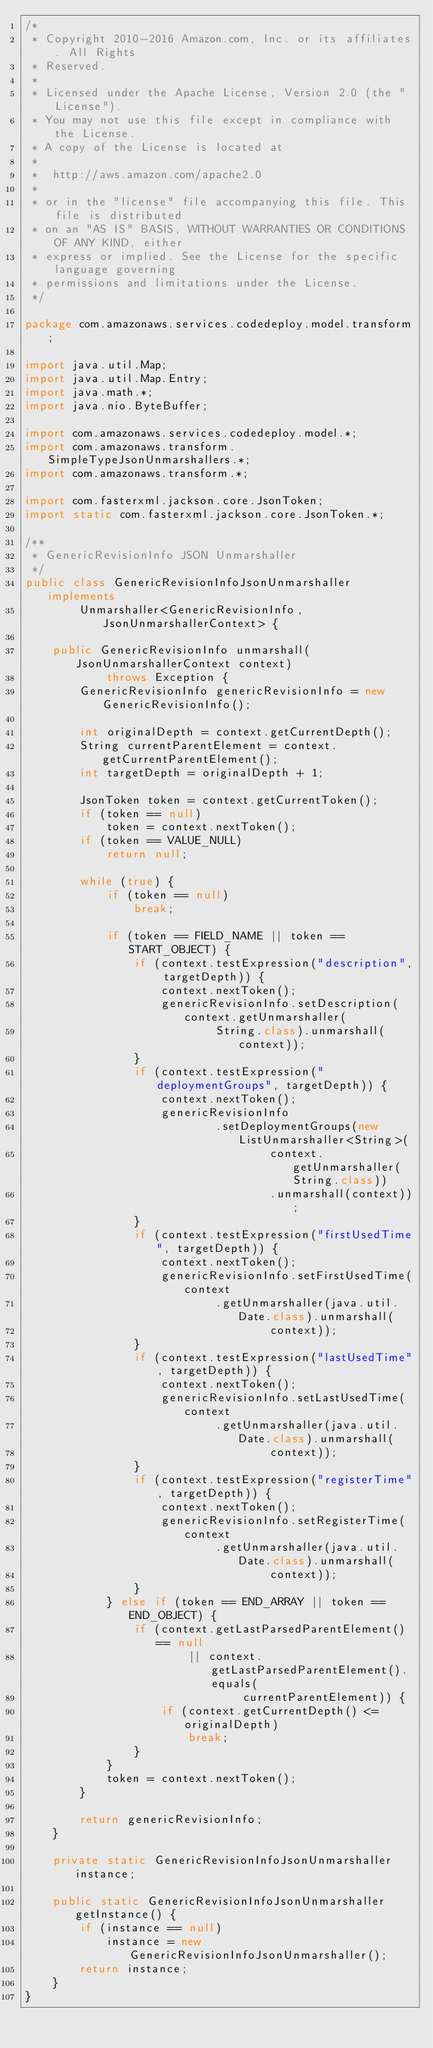Convert code to text. <code><loc_0><loc_0><loc_500><loc_500><_Java_>/*
 * Copyright 2010-2016 Amazon.com, Inc. or its affiliates. All Rights
 * Reserved.
 *
 * Licensed under the Apache License, Version 2.0 (the "License").
 * You may not use this file except in compliance with the License.
 * A copy of the License is located at
 *
 *  http://aws.amazon.com/apache2.0
 *
 * or in the "license" file accompanying this file. This file is distributed
 * on an "AS IS" BASIS, WITHOUT WARRANTIES OR CONDITIONS OF ANY KIND, either
 * express or implied. See the License for the specific language governing
 * permissions and limitations under the License.
 */

package com.amazonaws.services.codedeploy.model.transform;

import java.util.Map;
import java.util.Map.Entry;
import java.math.*;
import java.nio.ByteBuffer;

import com.amazonaws.services.codedeploy.model.*;
import com.amazonaws.transform.SimpleTypeJsonUnmarshallers.*;
import com.amazonaws.transform.*;

import com.fasterxml.jackson.core.JsonToken;
import static com.fasterxml.jackson.core.JsonToken.*;

/**
 * GenericRevisionInfo JSON Unmarshaller
 */
public class GenericRevisionInfoJsonUnmarshaller implements
        Unmarshaller<GenericRevisionInfo, JsonUnmarshallerContext> {

    public GenericRevisionInfo unmarshall(JsonUnmarshallerContext context)
            throws Exception {
        GenericRevisionInfo genericRevisionInfo = new GenericRevisionInfo();

        int originalDepth = context.getCurrentDepth();
        String currentParentElement = context.getCurrentParentElement();
        int targetDepth = originalDepth + 1;

        JsonToken token = context.getCurrentToken();
        if (token == null)
            token = context.nextToken();
        if (token == VALUE_NULL)
            return null;

        while (true) {
            if (token == null)
                break;

            if (token == FIELD_NAME || token == START_OBJECT) {
                if (context.testExpression("description", targetDepth)) {
                    context.nextToken();
                    genericRevisionInfo.setDescription(context.getUnmarshaller(
                            String.class).unmarshall(context));
                }
                if (context.testExpression("deploymentGroups", targetDepth)) {
                    context.nextToken();
                    genericRevisionInfo
                            .setDeploymentGroups(new ListUnmarshaller<String>(
                                    context.getUnmarshaller(String.class))
                                    .unmarshall(context));
                }
                if (context.testExpression("firstUsedTime", targetDepth)) {
                    context.nextToken();
                    genericRevisionInfo.setFirstUsedTime(context
                            .getUnmarshaller(java.util.Date.class).unmarshall(
                                    context));
                }
                if (context.testExpression("lastUsedTime", targetDepth)) {
                    context.nextToken();
                    genericRevisionInfo.setLastUsedTime(context
                            .getUnmarshaller(java.util.Date.class).unmarshall(
                                    context));
                }
                if (context.testExpression("registerTime", targetDepth)) {
                    context.nextToken();
                    genericRevisionInfo.setRegisterTime(context
                            .getUnmarshaller(java.util.Date.class).unmarshall(
                                    context));
                }
            } else if (token == END_ARRAY || token == END_OBJECT) {
                if (context.getLastParsedParentElement() == null
                        || context.getLastParsedParentElement().equals(
                                currentParentElement)) {
                    if (context.getCurrentDepth() <= originalDepth)
                        break;
                }
            }
            token = context.nextToken();
        }

        return genericRevisionInfo;
    }

    private static GenericRevisionInfoJsonUnmarshaller instance;

    public static GenericRevisionInfoJsonUnmarshaller getInstance() {
        if (instance == null)
            instance = new GenericRevisionInfoJsonUnmarshaller();
        return instance;
    }
}
</code> 